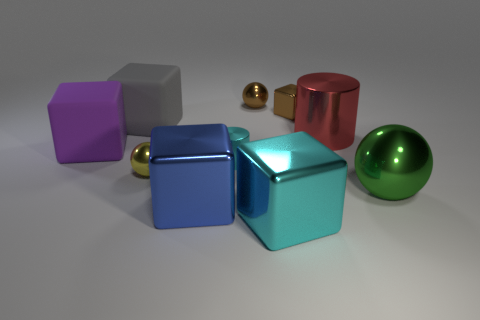What is the shape of the metal object that is the same color as the tiny shiny cube? sphere 